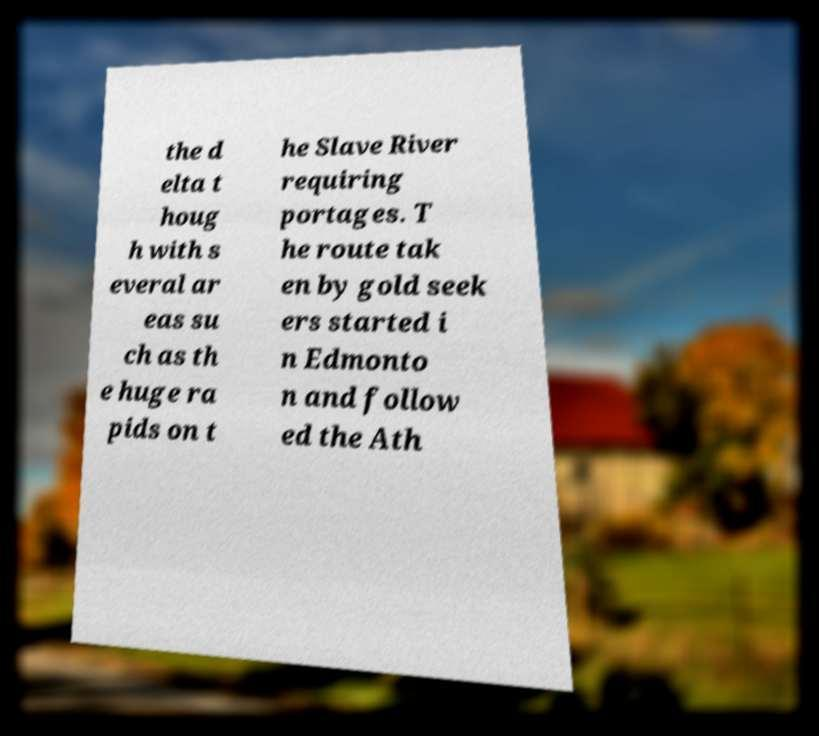Please identify and transcribe the text found in this image. the d elta t houg h with s everal ar eas su ch as th e huge ra pids on t he Slave River requiring portages. T he route tak en by gold seek ers started i n Edmonto n and follow ed the Ath 